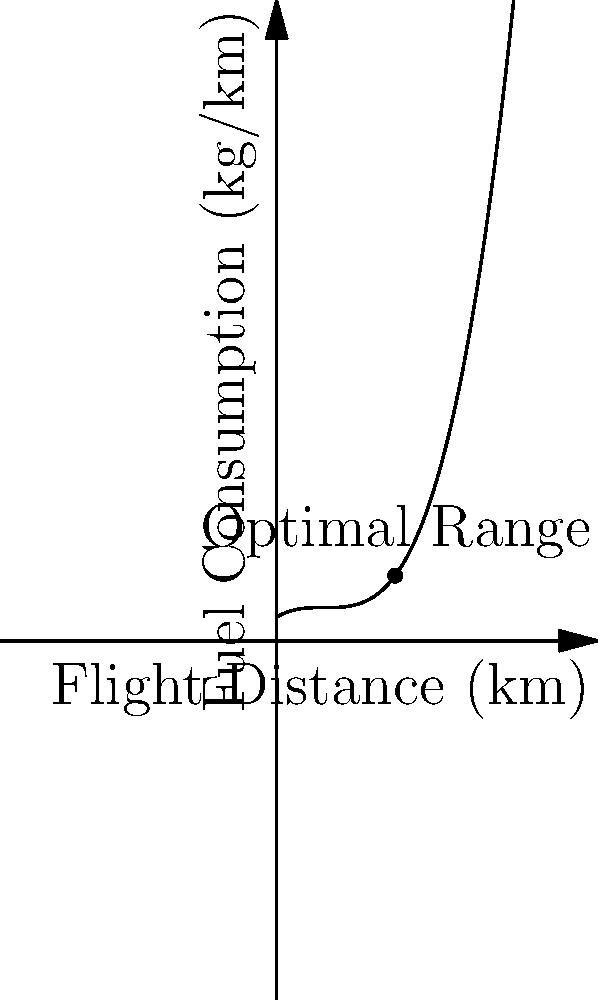Given the fuel consumption curve for an aircraft as shown in the graph, where fuel consumption (kg/km) is plotted against flight distance (km), determine the optimal flight distance for minimizing fuel consumption per kilometer. Assume that atmospheric conditions are constant and the aircraft maintains a steady cruise altitude. How would you use this information to optimize the airline's operations? To determine the optimal flight distance for minimizing fuel consumption, we need to follow these steps:

1. Analyze the graph: The curve represents fuel consumption (kg/km) as a function of flight distance (km).

2. Identify the minimum point: The lowest point on the curve indicates the minimum fuel consumption per kilometer.

3. Read the optimal distance: From the graph, we can see that the minimum point occurs at approximately 50 km.

4. Understand the implications:
   a. Shorter flights (< 50 km) have higher fuel consumption per km due to the energy required for takeoff and initial climb.
   b. Longer flights (> 50 km) also have higher fuel consumption per km, likely due to increased weight from additional fuel.

5. Optimize operations:
   a. Plan routes that favor segments close to the optimal 50 km distance.
   b. For longer routes, consider multiple stops at 50 km intervals if practical.
   c. Balance fuel efficiency with other factors like time, airport fees, and passenger preferences.

6. Consider other factors:
   a. Atmospheric conditions: Adjust flight paths to take advantage of favorable winds.
   b. Aircraft type: Different aircraft may have different optimal ranges.
   c. Payload: Adjust for variations in passenger and cargo load.

7. Implement in flight planning:
   a. Use this data in flight planning software to optimize routes.
   b. Train pilots on fuel-efficient flight techniques.
   c. Monitor and analyze actual flight data to refine the model.

By using this information, airlines can significantly reduce fuel consumption, lower operating costs, and minimize environmental impact while maintaining efficient operations.
Answer: Optimal flight distance: 50 km; Implement in route planning, consider multiple stops for longer flights, and adjust for specific aircraft and conditions. 